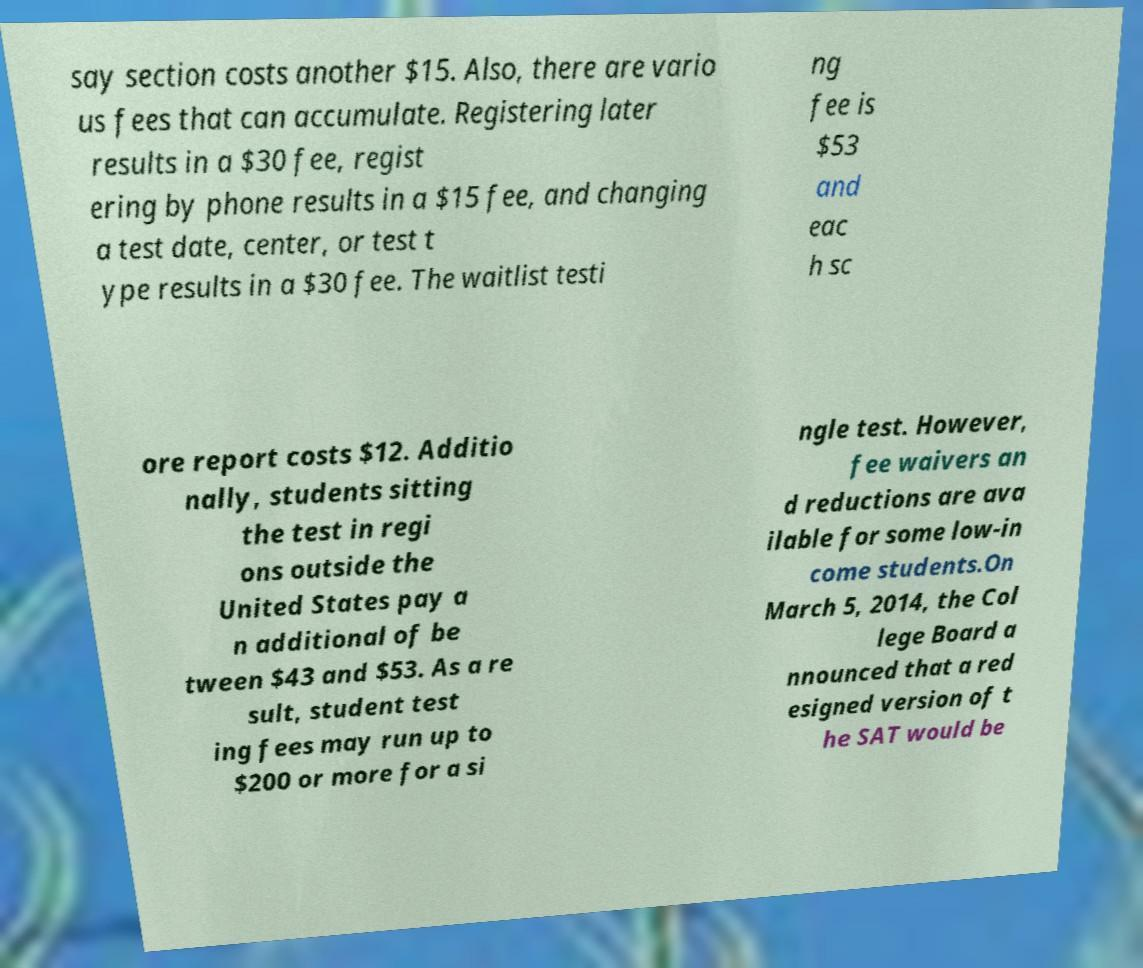For documentation purposes, I need the text within this image transcribed. Could you provide that? say section costs another $15. Also, there are vario us fees that can accumulate. Registering later results in a $30 fee, regist ering by phone results in a $15 fee, and changing a test date, center, or test t ype results in a $30 fee. The waitlist testi ng fee is $53 and eac h sc ore report costs $12. Additio nally, students sitting the test in regi ons outside the United States pay a n additional of be tween $43 and $53. As a re sult, student test ing fees may run up to $200 or more for a si ngle test. However, fee waivers an d reductions are ava ilable for some low-in come students.On March 5, 2014, the Col lege Board a nnounced that a red esigned version of t he SAT would be 